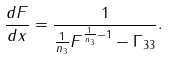<formula> <loc_0><loc_0><loc_500><loc_500>\frac { d F } { d x } = \frac { 1 } { \frac { 1 } { n _ { 3 } } F ^ { \frac { 1 } { n _ { 3 } } - 1 } - \Gamma _ { 3 3 } } .</formula> 